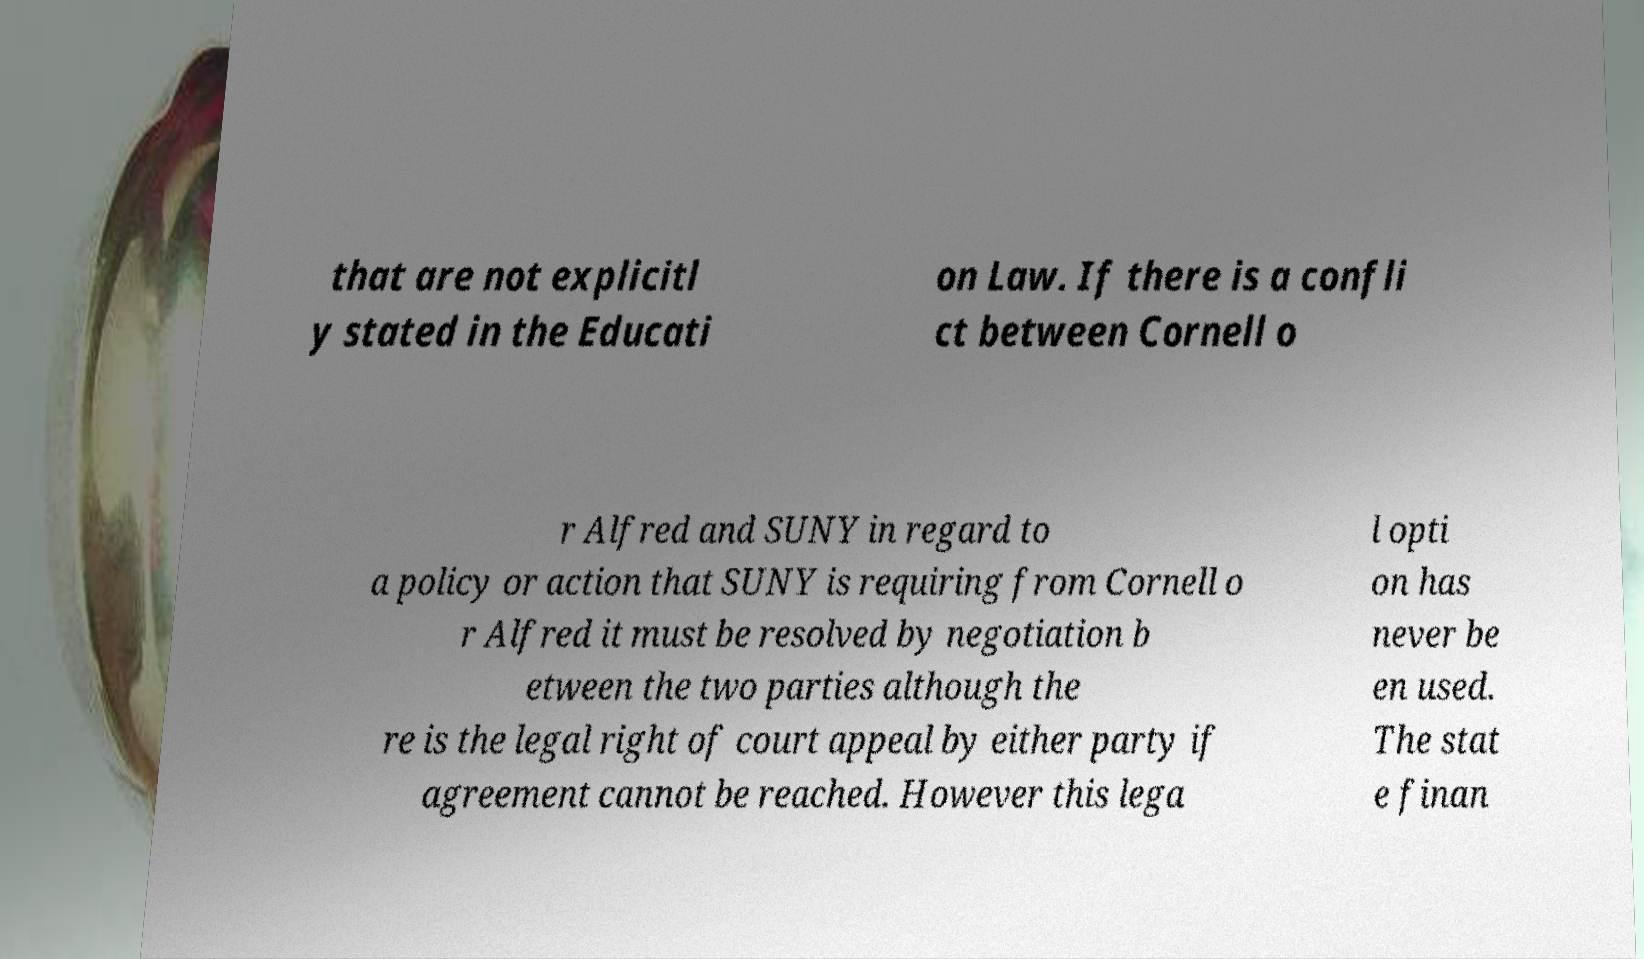Please read and relay the text visible in this image. What does it say? that are not explicitl y stated in the Educati on Law. If there is a confli ct between Cornell o r Alfred and SUNY in regard to a policy or action that SUNY is requiring from Cornell o r Alfred it must be resolved by negotiation b etween the two parties although the re is the legal right of court appeal by either party if agreement cannot be reached. However this lega l opti on has never be en used. The stat e finan 